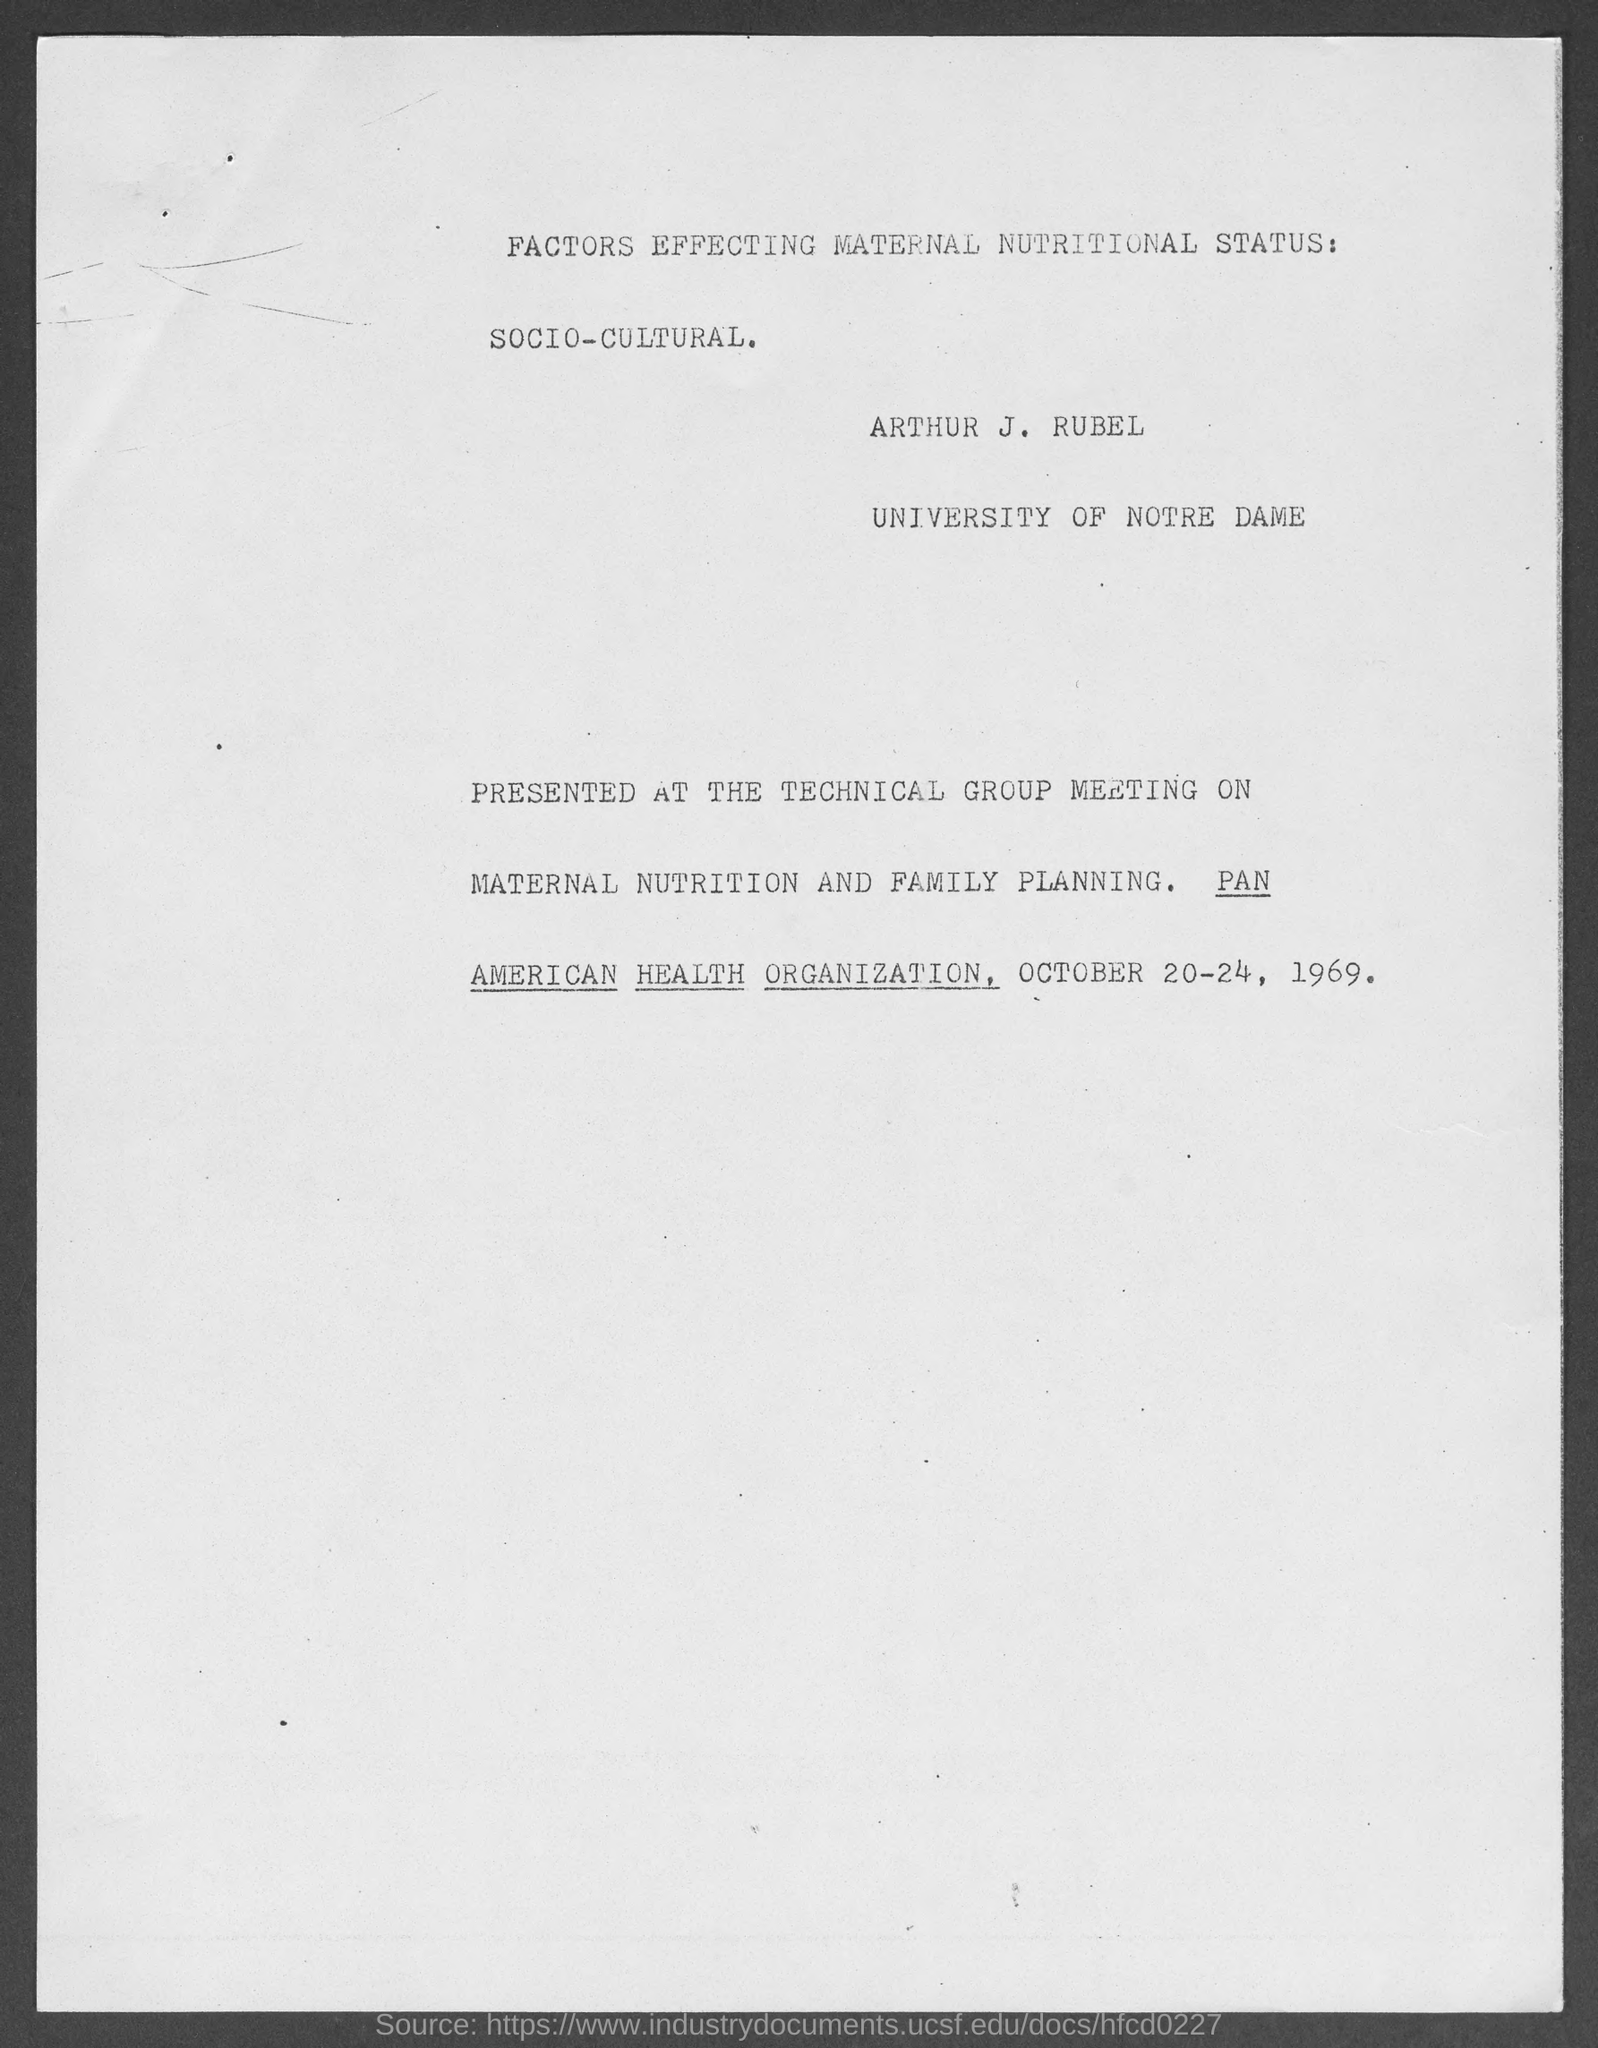What is the name of the person?
Give a very brief answer. Arthur J. Rubel. What is the name of the university?
Give a very brief answer. University of Notre Dame. What is the date mentioned in the document?
Offer a terse response. October 20-24, 1969. 